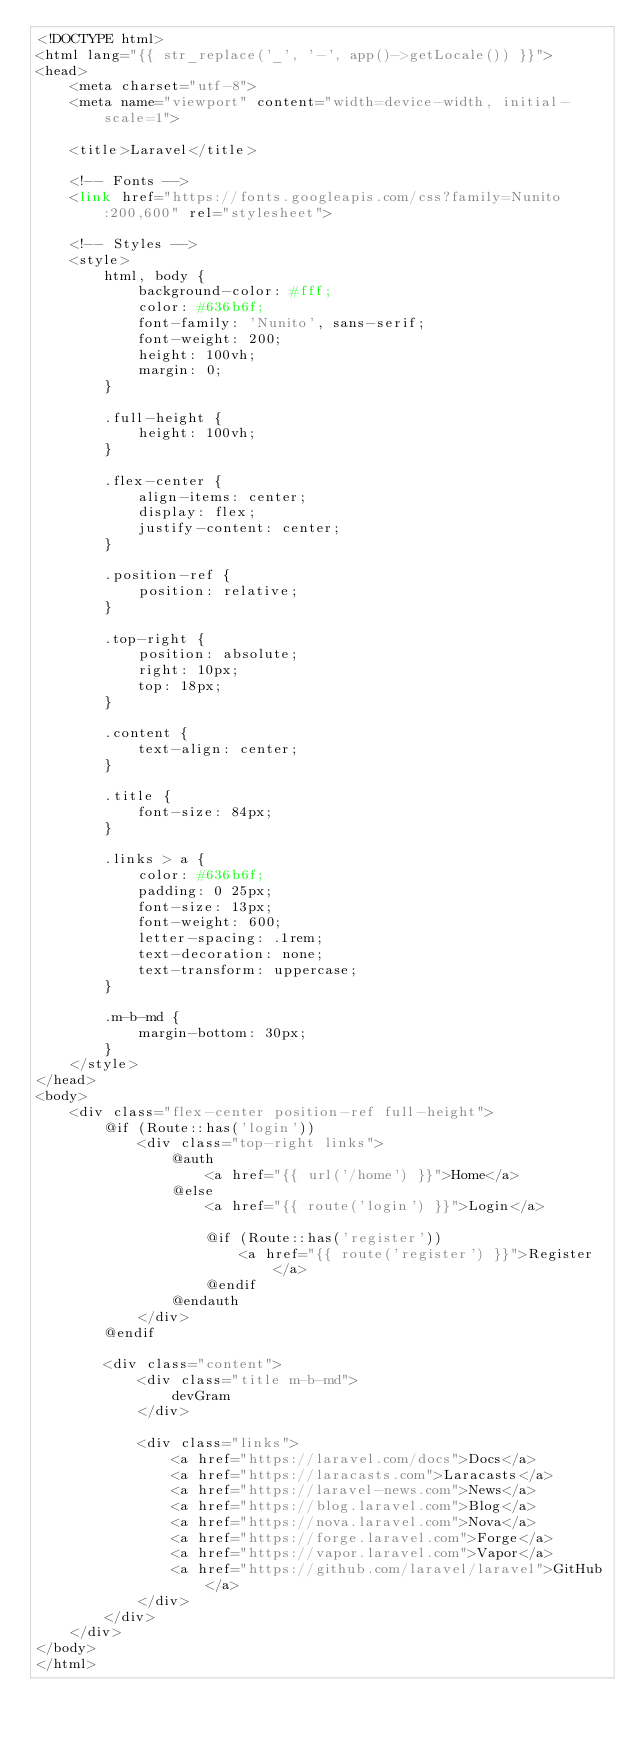Convert code to text. <code><loc_0><loc_0><loc_500><loc_500><_PHP_><!DOCTYPE html>
<html lang="{{ str_replace('_', '-', app()->getLocale()) }}">
<head>
    <meta charset="utf-8">
    <meta name="viewport" content="width=device-width, initial-scale=1">

    <title>Laravel</title>

    <!-- Fonts -->
    <link href="https://fonts.googleapis.com/css?family=Nunito:200,600" rel="stylesheet">

    <!-- Styles -->
    <style>
        html, body {
            background-color: #fff;
            color: #636b6f;
            font-family: 'Nunito', sans-serif;
            font-weight: 200;
            height: 100vh;
            margin: 0;
        }

        .full-height {
            height: 100vh;
        }

        .flex-center {
            align-items: center;
            display: flex;
            justify-content: center;
        }

        .position-ref {
            position: relative;
        }

        .top-right {
            position: absolute;
            right: 10px;
            top: 18px;
        }

        .content {
            text-align: center;
        }

        .title {
            font-size: 84px;
        }

        .links > a {
            color: #636b6f;
            padding: 0 25px;
            font-size: 13px;
            font-weight: 600;
            letter-spacing: .1rem;
            text-decoration: none;
            text-transform: uppercase;
        }

        .m-b-md {
            margin-bottom: 30px;
        }
    </style>
</head>
<body>
    <div class="flex-center position-ref full-height">
        @if (Route::has('login'))
            <div class="top-right links">
                @auth
                    <a href="{{ url('/home') }}">Home</a>
                @else
                    <a href="{{ route('login') }}">Login</a>

                    @if (Route::has('register'))
                        <a href="{{ route('register') }}">Register</a>
                    @endif
                @endauth
            </div>
        @endif

        <div class="content">
            <div class="title m-b-md">
                devGram
            </div>

            <div class="links">
                <a href="https://laravel.com/docs">Docs</a>
                <a href="https://laracasts.com">Laracasts</a>
                <a href="https://laravel-news.com">News</a>
                <a href="https://blog.laravel.com">Blog</a>
                <a href="https://nova.laravel.com">Nova</a>
                <a href="https://forge.laravel.com">Forge</a>
                <a href="https://vapor.laravel.com">Vapor</a>
                <a href="https://github.com/laravel/laravel">GitHub</a>
            </div>
        </div>
    </div>
</body>
</html>
</code> 